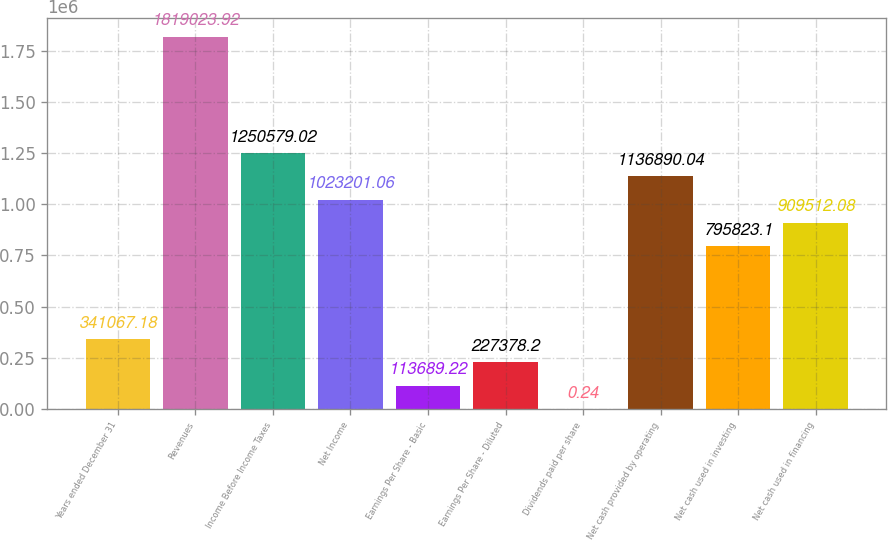Convert chart to OTSL. <chart><loc_0><loc_0><loc_500><loc_500><bar_chart><fcel>Years ended December 31<fcel>Revenues<fcel>Income Before Income Taxes<fcel>Net Income<fcel>Earnings Per Share - Basic<fcel>Earnings Per Share - Diluted<fcel>Dividends paid per share<fcel>Net cash provided by operating<fcel>Net cash used in investing<fcel>Net cash used in financing<nl><fcel>341067<fcel>1.81902e+06<fcel>1.25058e+06<fcel>1.0232e+06<fcel>113689<fcel>227378<fcel>0.24<fcel>1.13689e+06<fcel>795823<fcel>909512<nl></chart> 